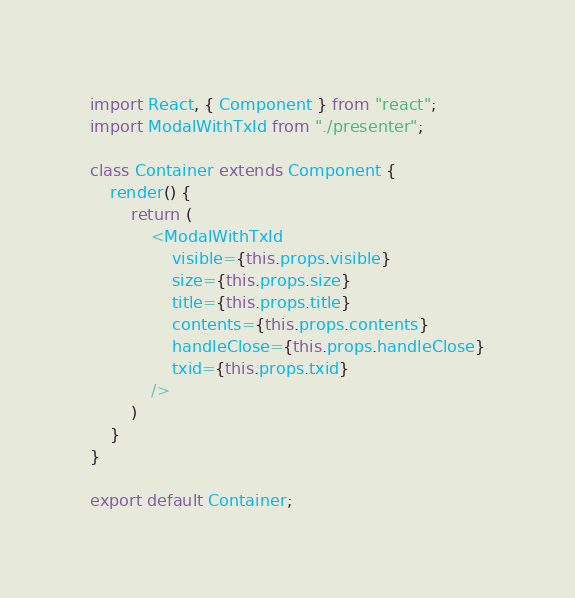Convert code to text. <code><loc_0><loc_0><loc_500><loc_500><_JavaScript_>import React, { Component } from "react";
import ModalWithTxId from "./presenter";

class Container extends Component {
    render() {
        return (
            <ModalWithTxId
                visible={this.props.visible}
                size={this.props.size}
                title={this.props.title}
                contents={this.props.contents}
                handleClose={this.props.handleClose}
                txid={this.props.txid}
            />
        )
    }    
}

export default Container;

</code> 